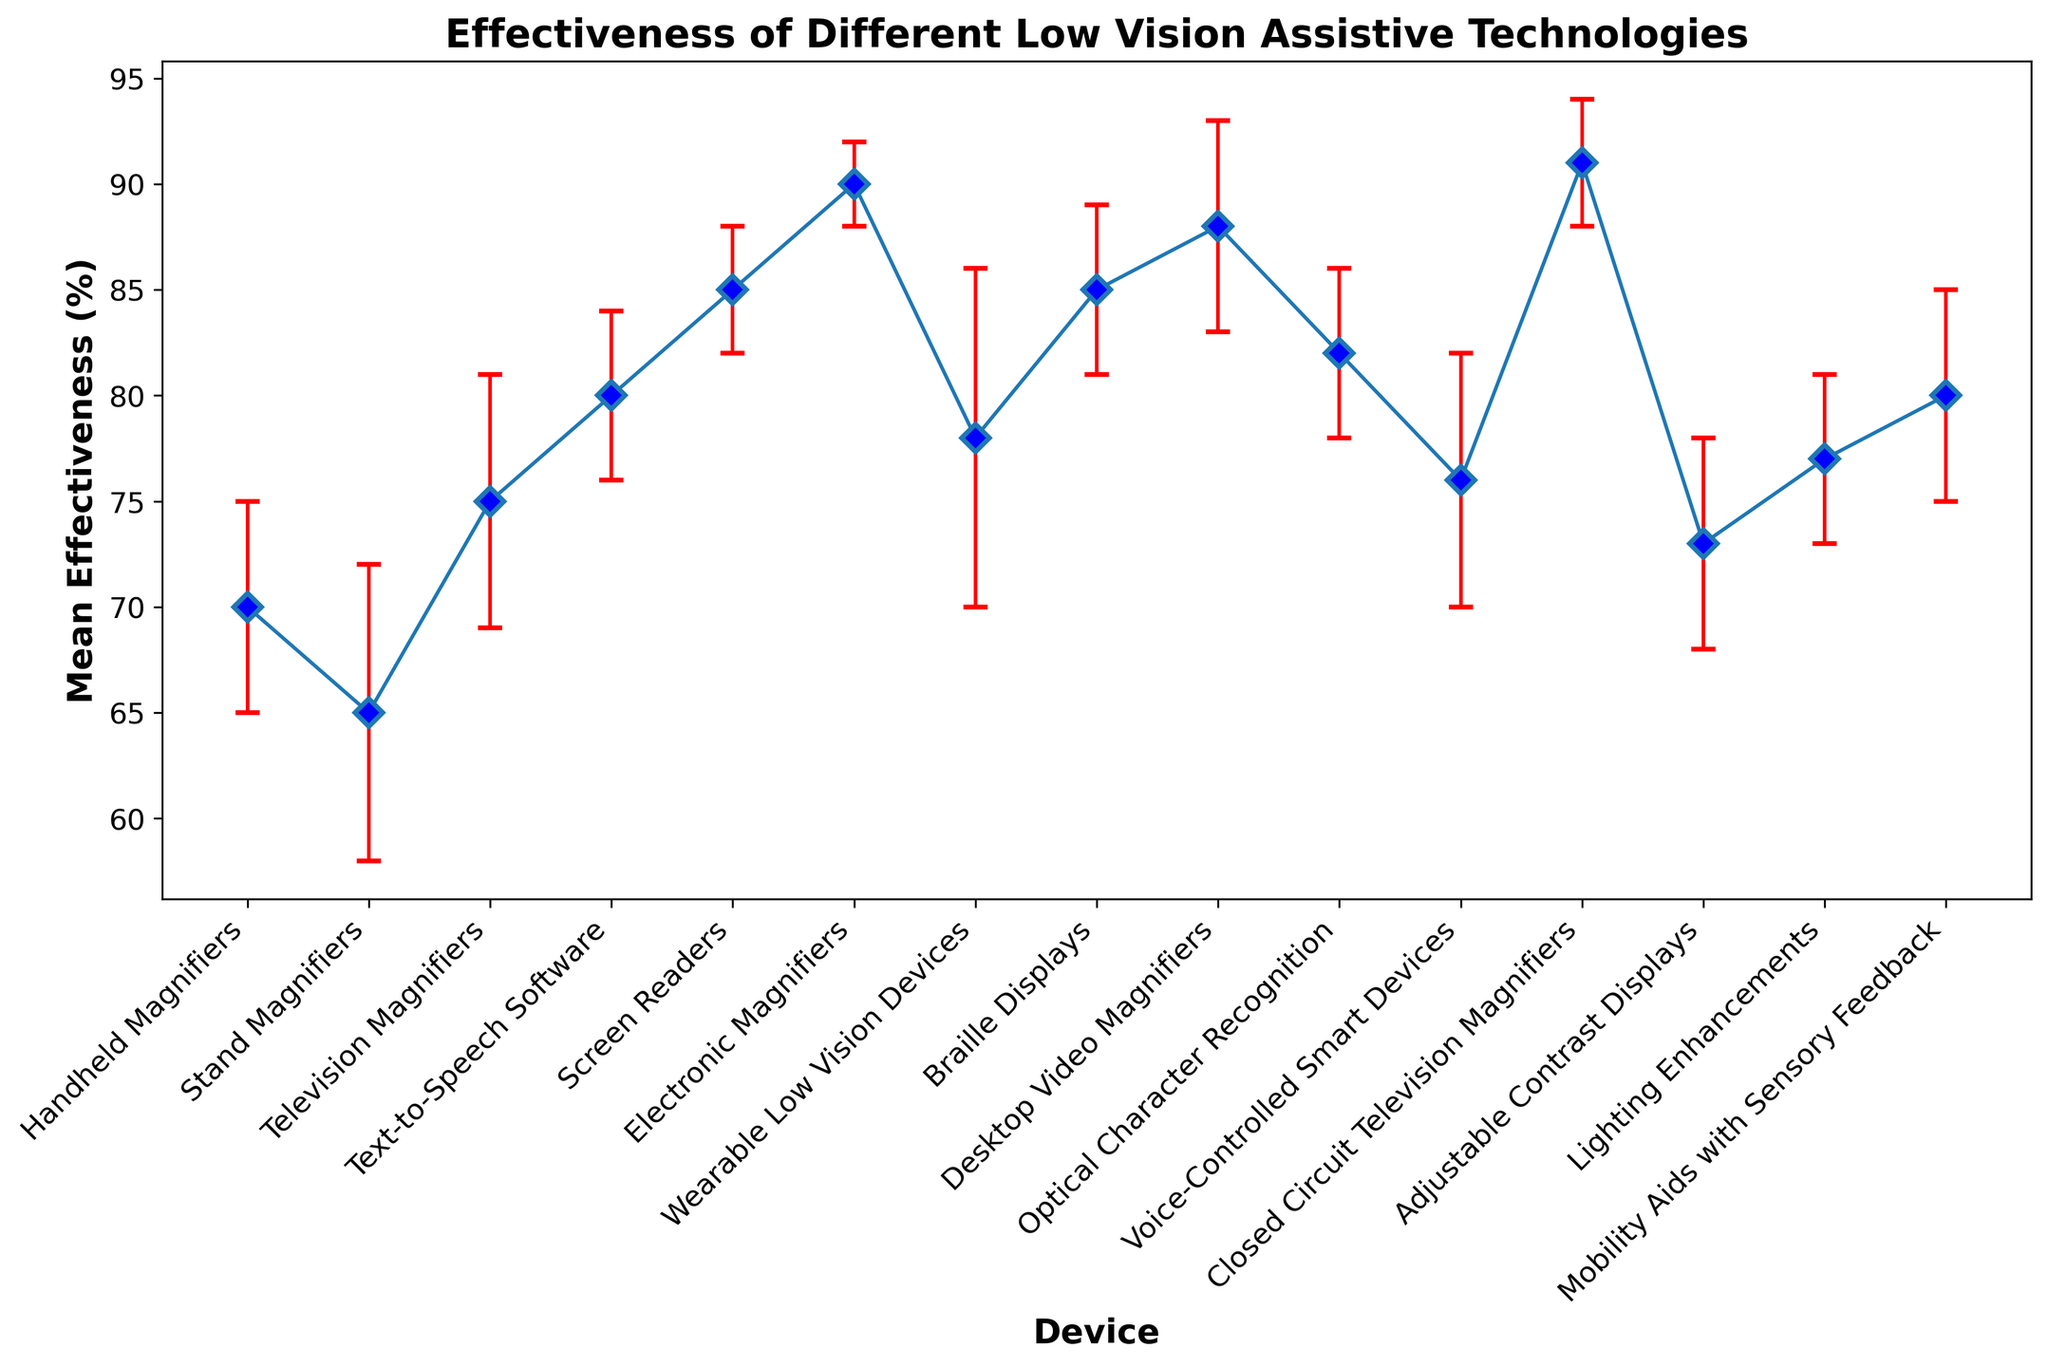Which device has the highest mean effectiveness? By examining the data points on the plot, the device with the highest mean effectiveness is Closed Circuit Television Magnifiers, shown at the top of the figure.
Answer: Closed Circuit Television Magnifiers What is the mean effectiveness of Text-to-Speech Software, and how does its error margin compare to that of Screen Readers? The mean effectiveness of Text-to-Speech Software is 80%, and its error margin is 4. The error margin of Screen Readers is 3, which is slightly smaller than that of Text-to-Speech Software.
Answer: 80%, smaller Which two devices have equal mean effectiveness but different error margins? Upon observing the plot, Braille Displays and Screen Readers both have a mean effectiveness of 85%. However, Braille Displays have an error margin of 4, while Screen Readers have an error margin of 3.
Answer: Braille Displays and Screen Readers Which device has the highest error margin, and what is its mean effectiveness? The device with the highest error margin is Wearable Low Vision Devices, with an error margin of 8, and its mean effectiveness is 78%.
Answer: Wearable Low Vision Devices, 78% Of the devices with a mean effectiveness above 80%, which one has the lowest error margin? The devices with mean effectiveness above 80% are Screen Readers, Electronic Magnifiers, Desktop Video Magnifiers, Optical Character Recognition, and Closed Circuit Television Magnifiers. Among these, Electronic Magnifiers have the lowest error margin of 2.
Answer: Electronic Magnifiers Which device has the smallest difference between its mean effectiveness and error margin? The difference for each device can be computed as mean effectiveness minus error margin. The device with the smallest difference is Electronic Magnifiers with a mean effectiveness of 90 and an error margin of 2, resulting in a difference of 88.
Answer: Electronic Magnifiers How does the mean effectiveness of Stand Magnifiers compare to that of Desktop Video Magnifiers? The mean effectiveness of Stand Magnifiers is 65%, and the mean effectiveness of Desktop Video Magnifiers is 88%. Desktop Video Magnifiers have a higher mean effectiveness compared to Stand Magnifiers.
Answer: Desktop Video Magnifiers are higher Which devices have an error margin of 4, and what are their mean effectiveness values? By looking at the plot, the devices with an error margin of 4 are Text-to-Speech Software, Braille Displays, Optical Character Recognition, and Lighting Enhancements. Their respective mean effectiveness values are 80%, 85%, 82%, and 77%.
Answer: Text-to-Speech Software (80%), Braille Displays (85%), Optical Character Recognition (82%), Lighting Enhancements (77%) Among the devices with mean effectiveness below 75%, which one has the highest mean effectiveness? The devices below 75% mean effectiveness are Stand Magnifiers, Handheld Magnifiers, and Adjustable Contrast Displays. Handheld Magnifiers have the highest mean effectiveness among them at 70%.
Answer: Handheld Magnifiers 